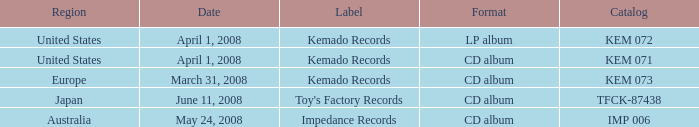Could you parse the entire table? {'header': ['Region', 'Date', 'Label', 'Format', 'Catalog'], 'rows': [['United States', 'April 1, 2008', 'Kemado Records', 'LP album', 'KEM 072'], ['United States', 'April 1, 2008', 'Kemado Records', 'CD album', 'KEM 071'], ['Europe', 'March 31, 2008', 'Kemado Records', 'CD album', 'KEM 073'], ['Japan', 'June 11, 2008', "Toy's Factory Records", 'CD album', 'TFCK-87438'], ['Australia', 'May 24, 2008', 'Impedance Records', 'CD album', 'IMP 006']]} Which Format has a Label of toy's factory records? CD album. 